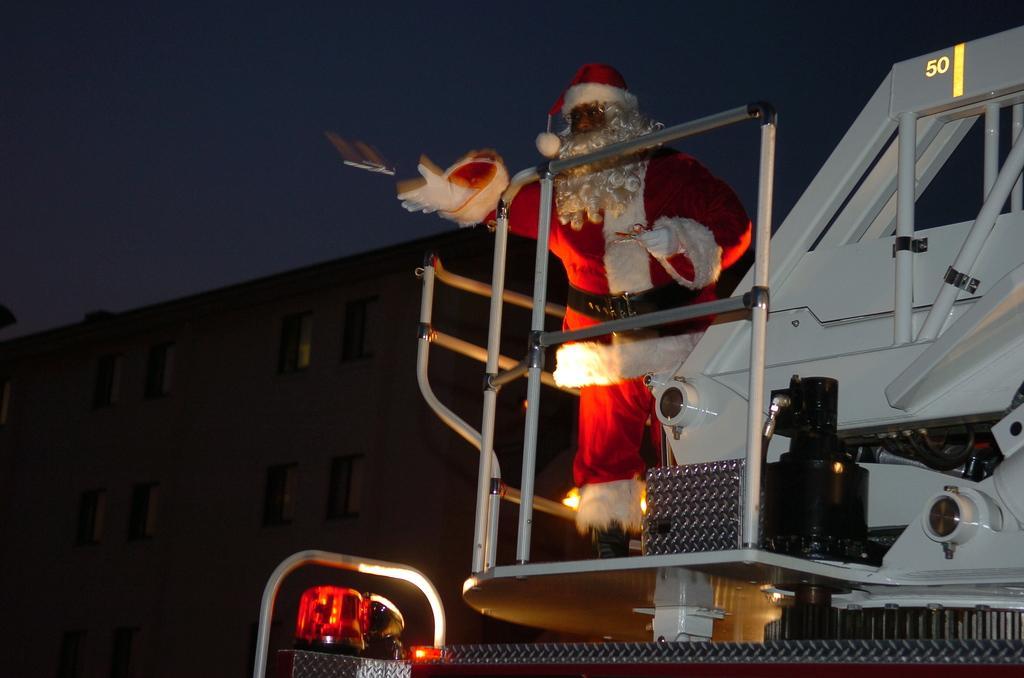Can you describe this image briefly? In this image there is a santa claus standing on some vehicle behind him there is a building. 